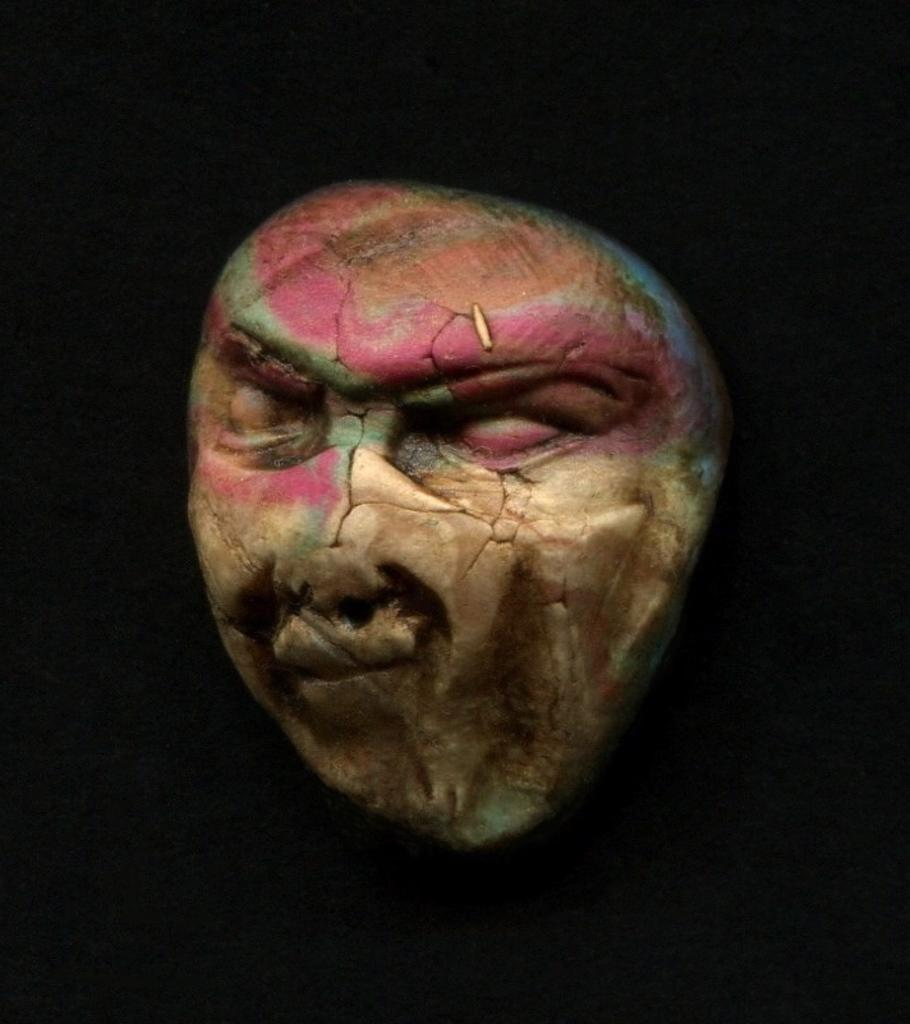What is the main subject of the image? The main subject of the image is either an artifact or a skull. What can be observed about the background of the image? The background of the image is dark. How many kittens are participating in the feast in the image? There are no kittens or feast present in the image. What word is written on the artifact or skull in the image? There is no word visible on the artifact or skull in the image. 